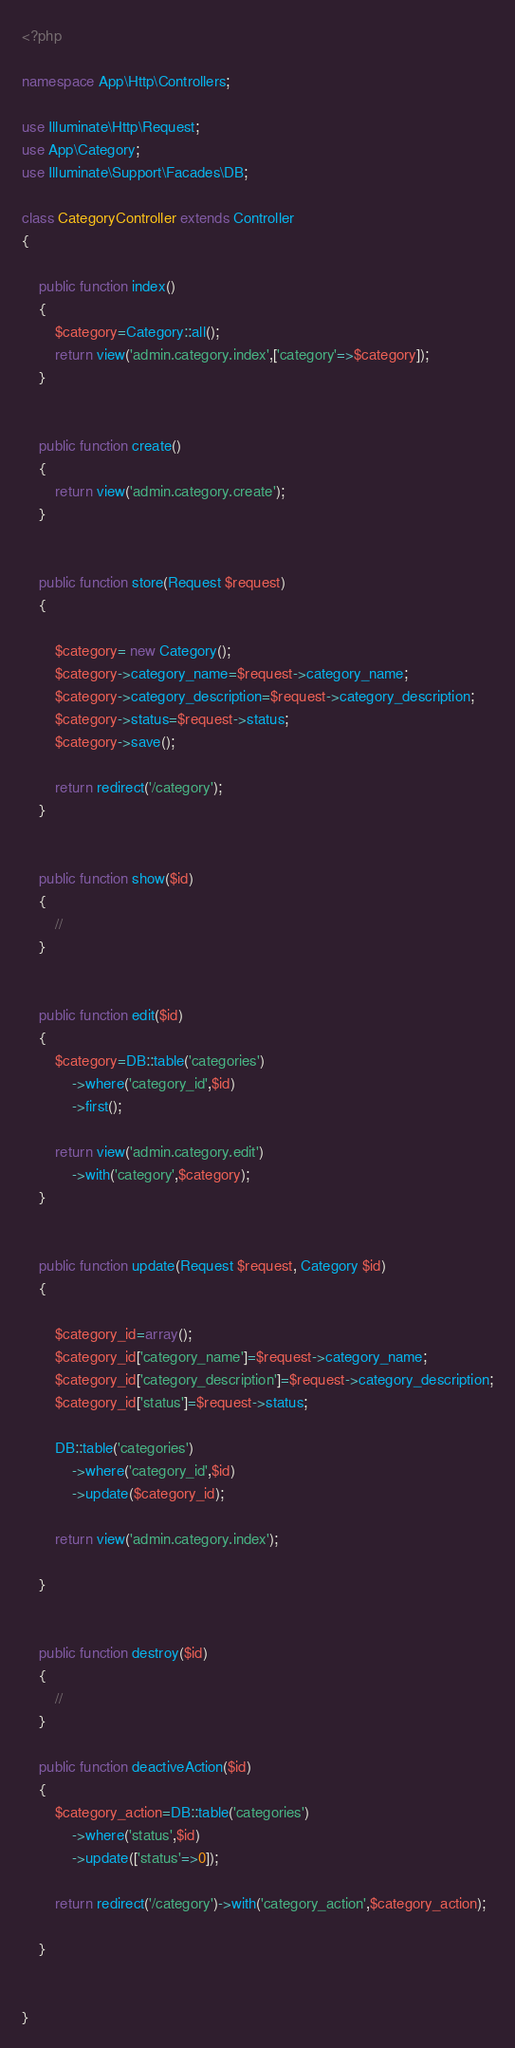Convert code to text. <code><loc_0><loc_0><loc_500><loc_500><_PHP_><?php

namespace App\Http\Controllers;

use Illuminate\Http\Request;
use App\Category;
use Illuminate\Support\Facades\DB;

class CategoryController extends Controller
{

    public function index()
    {
        $category=Category::all();
        return view('admin.category.index',['category'=>$category]);
    }


    public function create()
    {
        return view('admin.category.create');
    }


    public function store(Request $request)
    {

        $category= new Category();
        $category->category_name=$request->category_name;
        $category->category_description=$request->category_description;
        $category->status=$request->status;
        $category->save();

        return redirect('/category');
    }


    public function show($id)
    {
        //
    }


    public function edit($id)
    {
        $category=DB::table('categories')
            ->where('category_id',$id)
            ->first();

        return view('admin.category.edit')
            ->with('category',$category);
    }


    public function update(Request $request, Category $id)
    {

        $category_id=array();
        $category_id['category_name']=$request->category_name;
        $category_id['category_description']=$request->category_description;
        $category_id['status']=$request->status;

        DB::table('categories')
            ->where('category_id',$id)
            ->update($category_id);

        return view('admin.category.index');

    }


    public function destroy($id)
    {
        //
    }

    public function deactiveAction($id)
    {
        $category_action=DB::table('categories')
            ->where('status',$id)
            ->update(['status'=>0]);

        return redirect('/category')->with('category_action',$category_action);

    }


}
</code> 